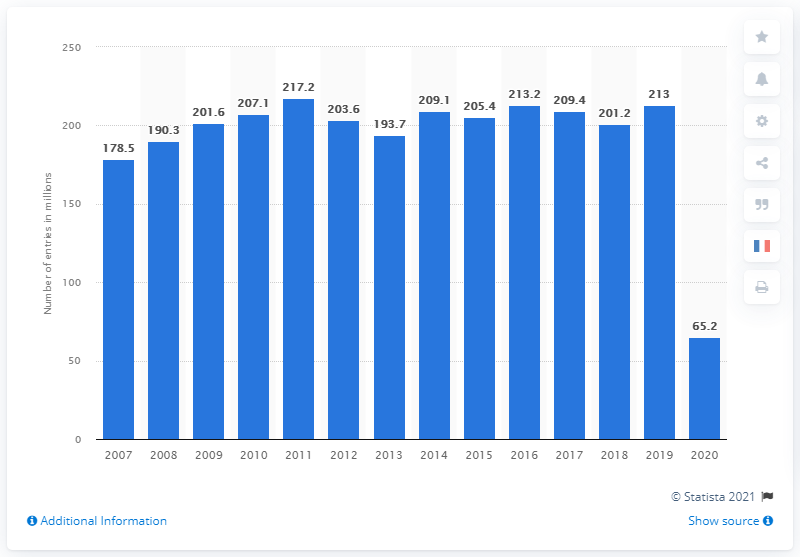Outline some significant characteristics in this image. In 2019, the number of cinemas in France was 213. The total attendance at cinemas in France between 2007 and 2020 was approximately 65.2 million. 